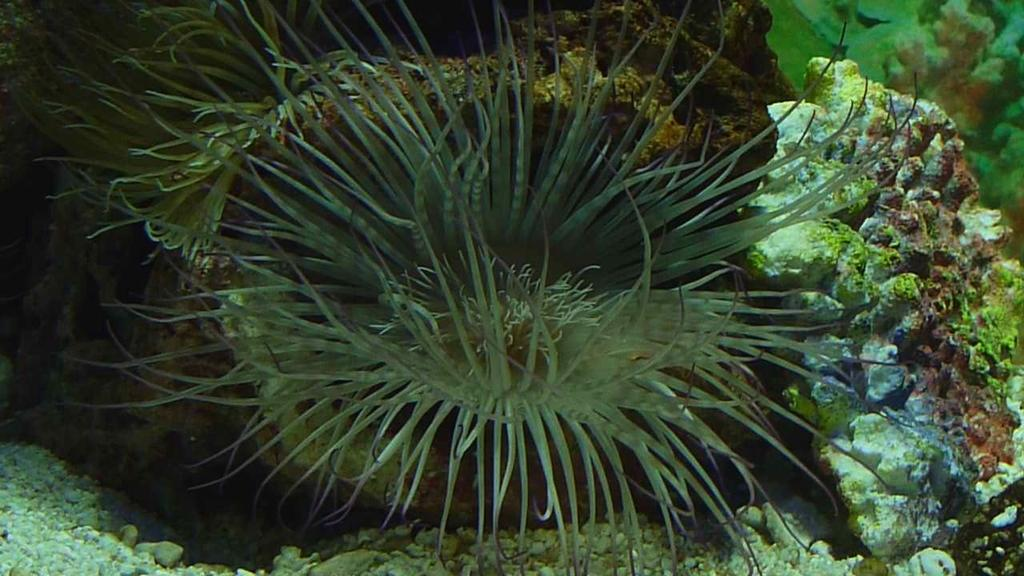What type of vegetation can be seen in the image? There are many plants in the image. Where are the plants located? The plants are on the land. Can you describe the plants in more detail? The plants appear to be aquatic plants. What type of glass can be seen in the image? There is no glass present in the image; it only features plants. 